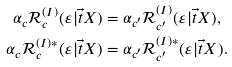Convert formula to latex. <formula><loc_0><loc_0><loc_500><loc_500>\alpha _ { c } \mathcal { R } _ { c } ^ { ( I ) } ( \varepsilon | \vec { t } { X } ) & = \alpha _ { c ^ { \prime } } \mathcal { R } _ { c ^ { \prime } } ^ { ( I ) } ( \varepsilon | \vec { t } { X } ) , \\ \alpha _ { c } \mathcal { R } _ { c } ^ { ( I ) * } ( \varepsilon | \vec { t } { X } ) & = \alpha _ { c ^ { \prime } } \mathcal { R } _ { c ^ { \prime } } ^ { ( I ) * } ( \varepsilon | \vec { t } { X } ) .</formula> 